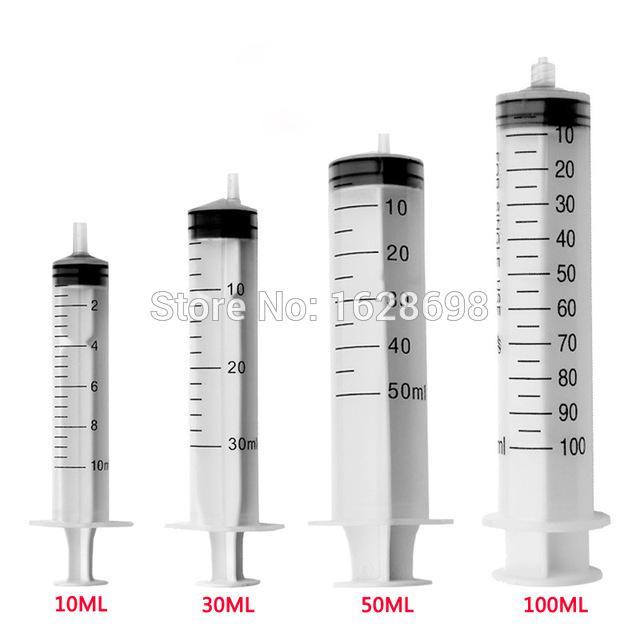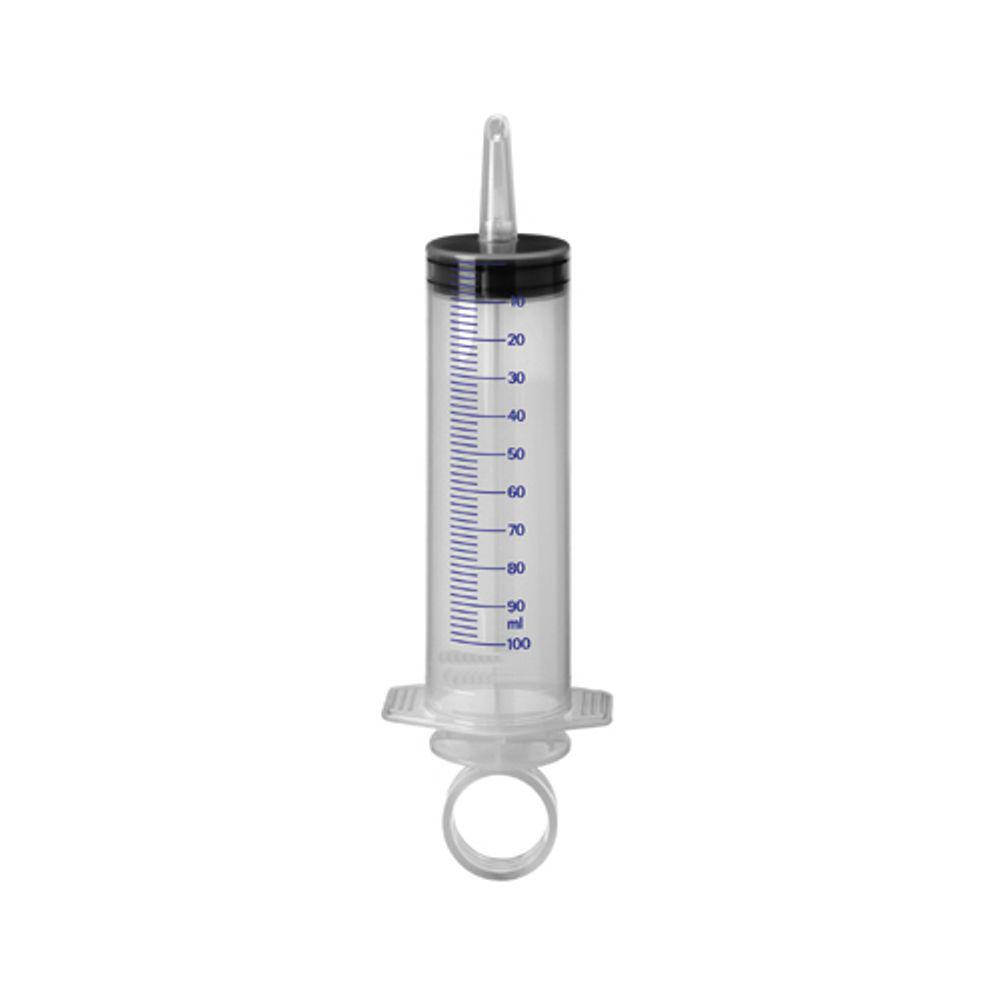The first image is the image on the left, the second image is the image on the right. Considering the images on both sides, is "One of the images shows only one syringe, and it has a ring on the end of it." valid? Answer yes or no. Yes. 